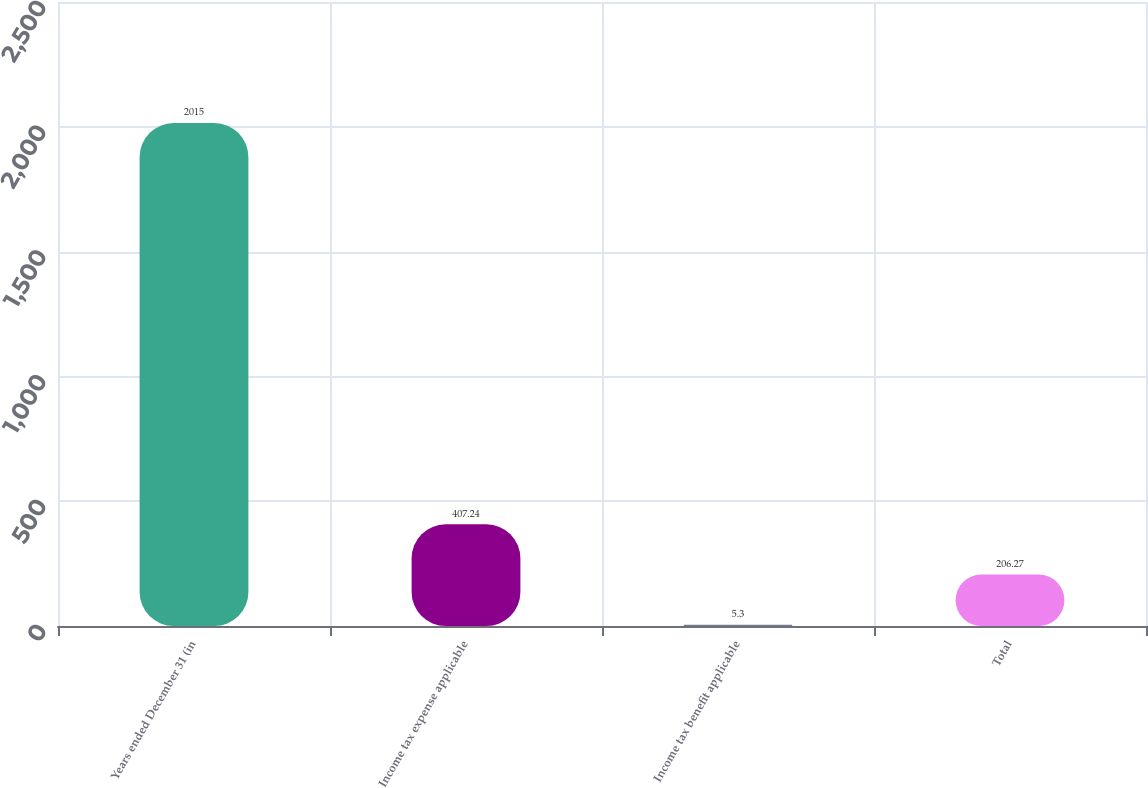<chart> <loc_0><loc_0><loc_500><loc_500><bar_chart><fcel>Years ended December 31 (in<fcel>Income tax expense applicable<fcel>Income tax benefit applicable<fcel>Total<nl><fcel>2015<fcel>407.24<fcel>5.3<fcel>206.27<nl></chart> 